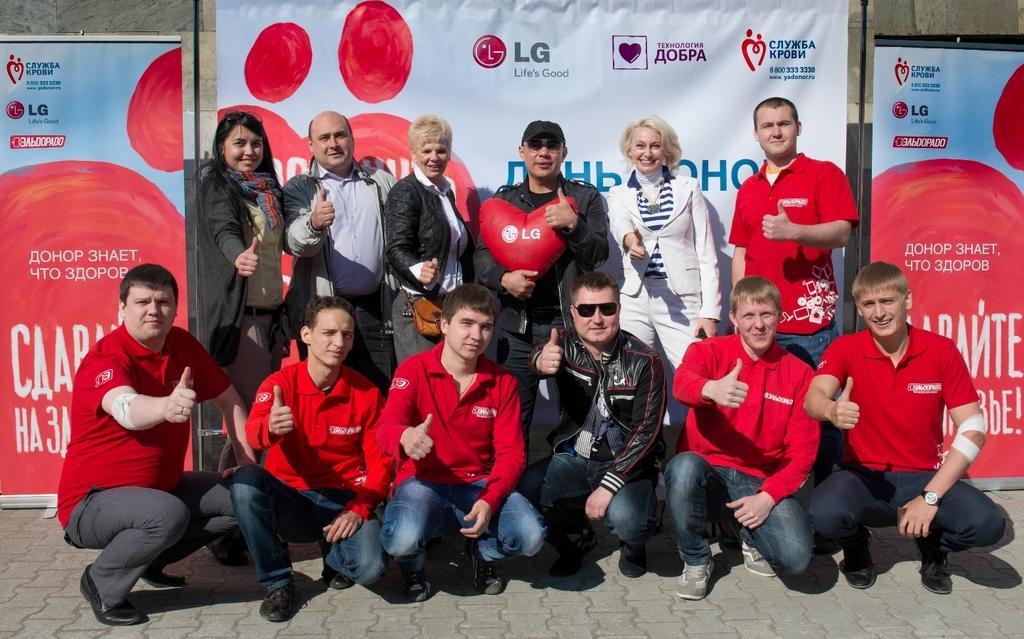Can you describe this image briefly? In this picture I can see a group of people in the middle. In the background there are banners. 